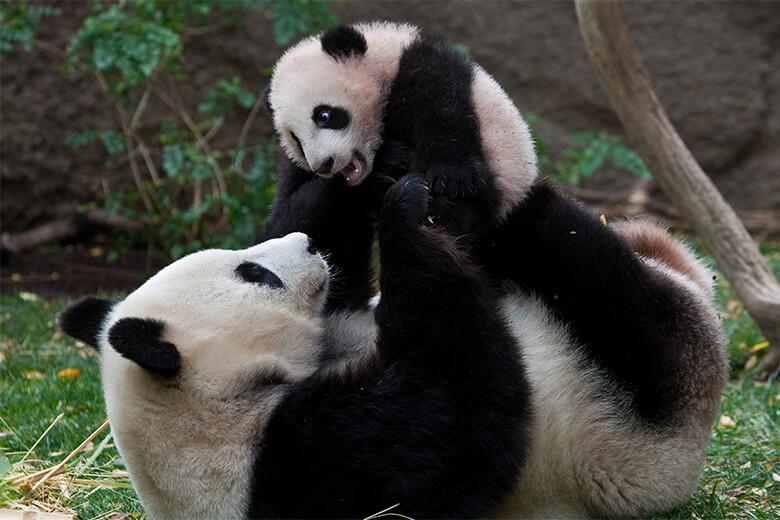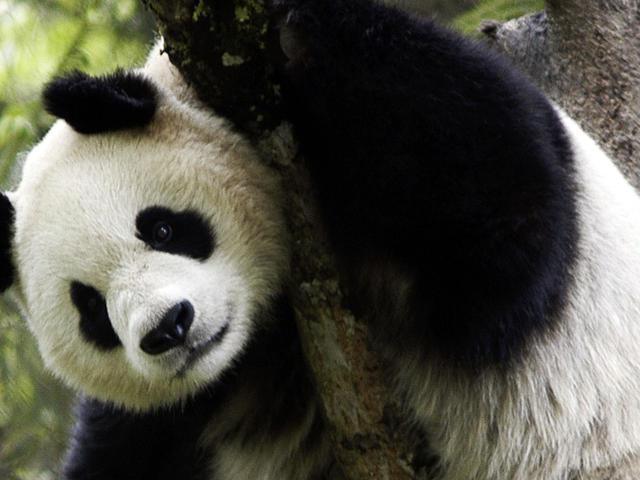The first image is the image on the left, the second image is the image on the right. Evaluate the accuracy of this statement regarding the images: "There are no more than 3 pandas in the image pair". Is it true? Answer yes or no. Yes. The first image is the image on the left, the second image is the image on the right. For the images shown, is this caption "One image features a baby panda next to an adult panda" true? Answer yes or no. Yes. 